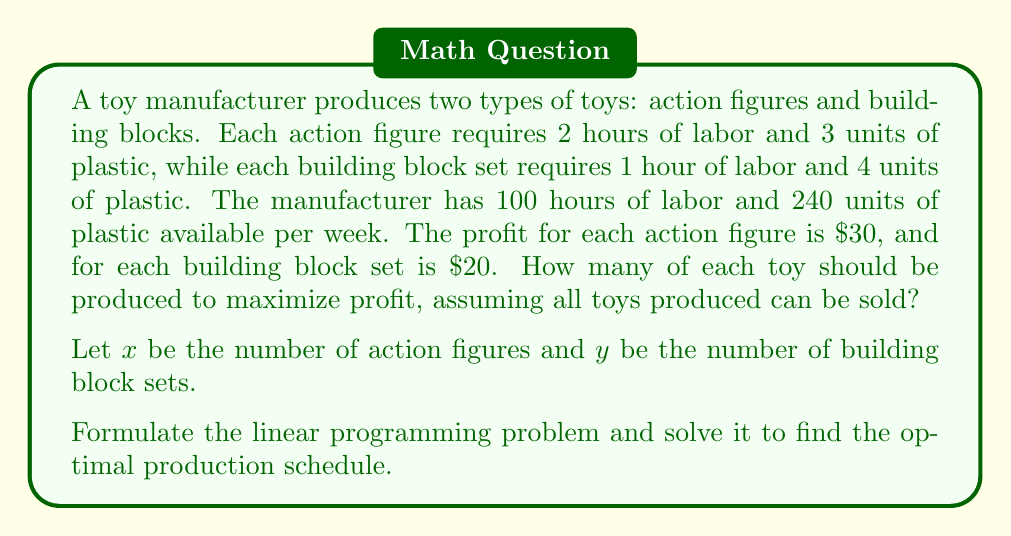Could you help me with this problem? 1. Formulate the linear programming problem:

Objective function (maximize profit):
$$Z = 30x + 20y$$

Constraints:
Labor: $$2x + y \leq 100$$
Plastic: $$3x + 4y \leq 240$$
Non-negativity: $$x \geq 0, y \geq 0$$

2. Graph the constraints:
Labor constraint: $y = 100 - 2x$
Plastic constraint: $y = 60 - \frac{3}{4}x$

3. Find the vertices of the feasible region:
(0, 0), (0, 60), (40, 20), (50, 0)

4. Evaluate the objective function at each vertex:
(0, 0): $Z = 0$
(0, 60): $Z = 1200$
(40, 20): $Z = 1600$
(50, 0): $Z = 1500$

5. The maximum profit occurs at the point (40, 20).

Therefore, the optimal production schedule is to produce 40 action figures and 20 building block sets.
Answer: 40 action figures, 20 building block sets 